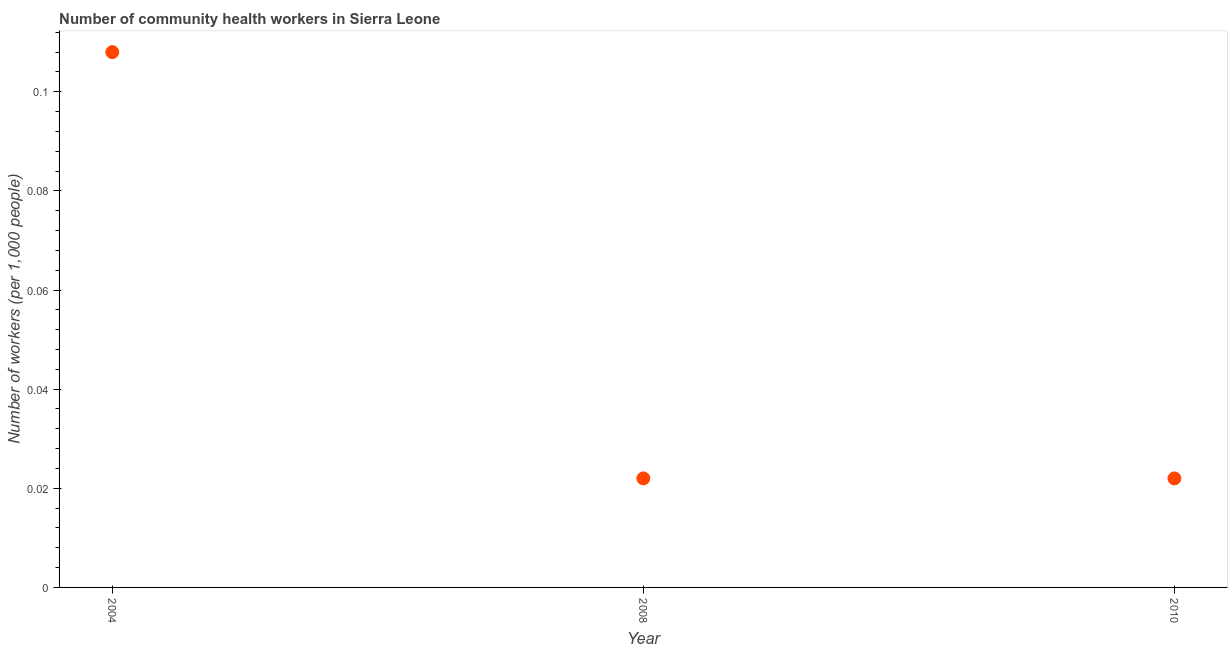What is the number of community health workers in 2010?
Your answer should be very brief. 0.02. Across all years, what is the maximum number of community health workers?
Provide a short and direct response. 0.11. Across all years, what is the minimum number of community health workers?
Make the answer very short. 0.02. In which year was the number of community health workers maximum?
Your response must be concise. 2004. In which year was the number of community health workers minimum?
Provide a succinct answer. 2008. What is the sum of the number of community health workers?
Ensure brevity in your answer.  0.15. What is the difference between the number of community health workers in 2008 and 2010?
Offer a very short reply. 0. What is the average number of community health workers per year?
Your answer should be compact. 0.05. What is the median number of community health workers?
Give a very brief answer. 0.02. In how many years, is the number of community health workers greater than 0.064 ?
Offer a very short reply. 1. Do a majority of the years between 2004 and 2008 (inclusive) have number of community health workers greater than 0.08 ?
Ensure brevity in your answer.  No. What is the ratio of the number of community health workers in 2004 to that in 2010?
Provide a short and direct response. 4.91. What is the difference between the highest and the second highest number of community health workers?
Provide a succinct answer. 0.09. What is the difference between the highest and the lowest number of community health workers?
Provide a short and direct response. 0.09. In how many years, is the number of community health workers greater than the average number of community health workers taken over all years?
Keep it short and to the point. 1. What is the difference between two consecutive major ticks on the Y-axis?
Give a very brief answer. 0.02. Are the values on the major ticks of Y-axis written in scientific E-notation?
Ensure brevity in your answer.  No. Does the graph contain any zero values?
Your answer should be very brief. No. What is the title of the graph?
Make the answer very short. Number of community health workers in Sierra Leone. What is the label or title of the X-axis?
Give a very brief answer. Year. What is the label or title of the Y-axis?
Give a very brief answer. Number of workers (per 1,0 people). What is the Number of workers (per 1,000 people) in 2004?
Keep it short and to the point. 0.11. What is the Number of workers (per 1,000 people) in 2008?
Provide a succinct answer. 0.02. What is the Number of workers (per 1,000 people) in 2010?
Offer a terse response. 0.02. What is the difference between the Number of workers (per 1,000 people) in 2004 and 2008?
Give a very brief answer. 0.09. What is the difference between the Number of workers (per 1,000 people) in 2004 and 2010?
Make the answer very short. 0.09. What is the difference between the Number of workers (per 1,000 people) in 2008 and 2010?
Ensure brevity in your answer.  0. What is the ratio of the Number of workers (per 1,000 people) in 2004 to that in 2008?
Keep it short and to the point. 4.91. What is the ratio of the Number of workers (per 1,000 people) in 2004 to that in 2010?
Make the answer very short. 4.91. What is the ratio of the Number of workers (per 1,000 people) in 2008 to that in 2010?
Offer a very short reply. 1. 